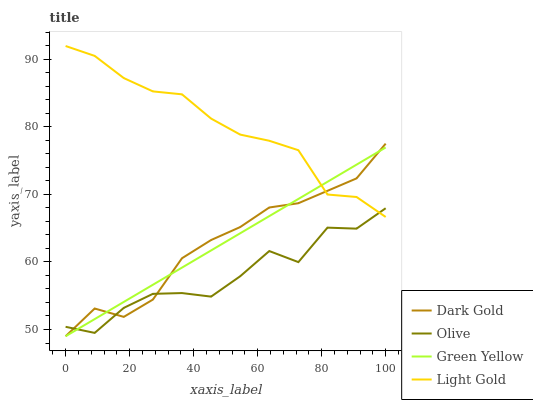Does Olive have the minimum area under the curve?
Answer yes or no. Yes. Does Light Gold have the maximum area under the curve?
Answer yes or no. Yes. Does Green Yellow have the minimum area under the curve?
Answer yes or no. No. Does Green Yellow have the maximum area under the curve?
Answer yes or no. No. Is Green Yellow the smoothest?
Answer yes or no. Yes. Is Olive the roughest?
Answer yes or no. Yes. Is Light Gold the smoothest?
Answer yes or no. No. Is Light Gold the roughest?
Answer yes or no. No. Does Light Gold have the lowest value?
Answer yes or no. No. Does Light Gold have the highest value?
Answer yes or no. Yes. Does Green Yellow have the highest value?
Answer yes or no. No. Does Light Gold intersect Green Yellow?
Answer yes or no. Yes. Is Light Gold less than Green Yellow?
Answer yes or no. No. Is Light Gold greater than Green Yellow?
Answer yes or no. No. 